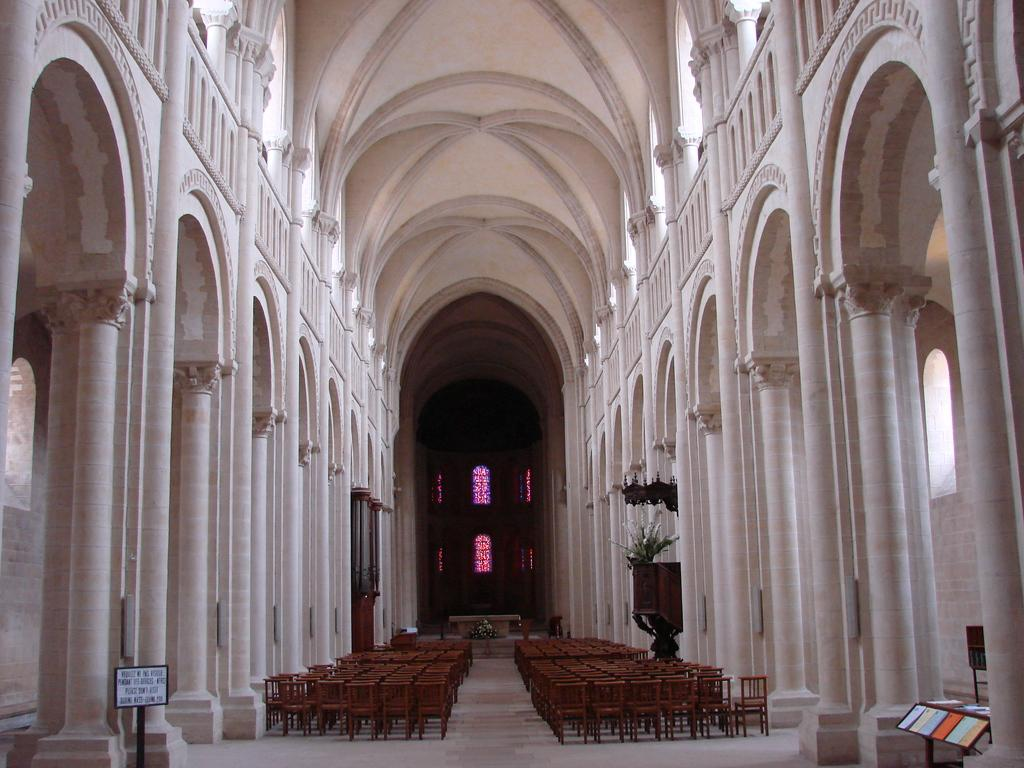What type of furniture is located at the bottom side of the image? There are chairs at the bottom side of the image. What architectural features can be seen on the right side of the image? There are pillars on the right side of the image. What architectural features can be seen on the left side of the image? There are pillars on the left side of the image. What can be seen in the center of the image? There are windows in the center of the image. What type of test is being conducted in the image? There is no test being conducted in the image; it features chairs, pillars, and windows. Can you hear the band playing in the image? There is no band present in the image, so it is not possible to hear them playing. 